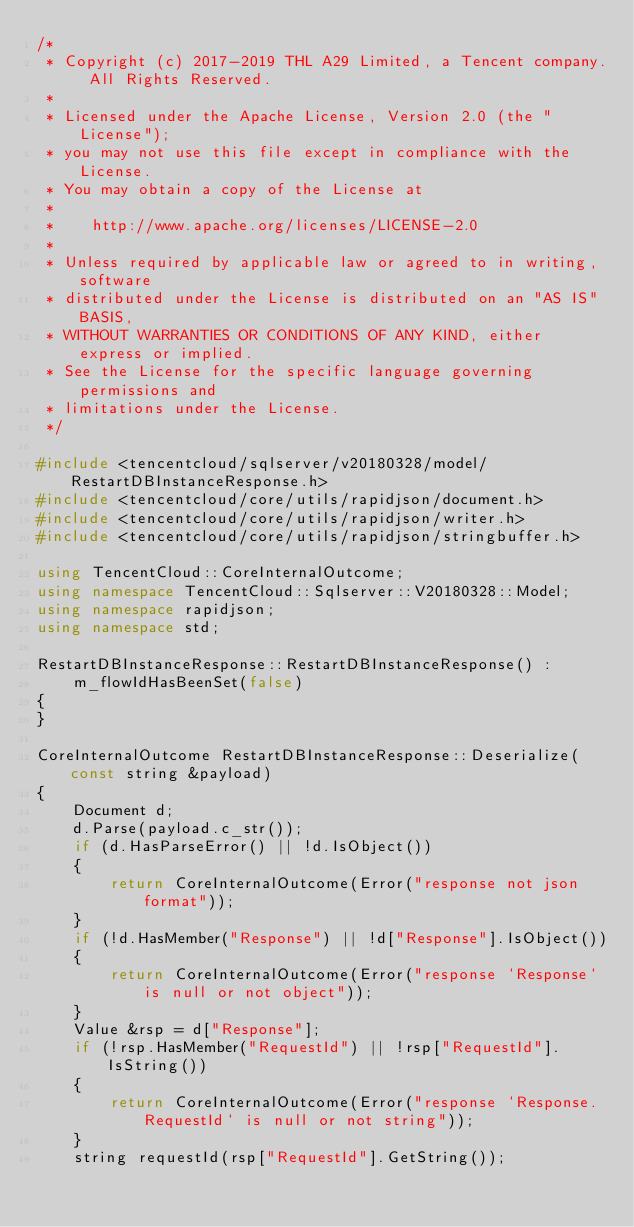<code> <loc_0><loc_0><loc_500><loc_500><_C++_>/*
 * Copyright (c) 2017-2019 THL A29 Limited, a Tencent company. All Rights Reserved.
 *
 * Licensed under the Apache License, Version 2.0 (the "License");
 * you may not use this file except in compliance with the License.
 * You may obtain a copy of the License at
 *
 *    http://www.apache.org/licenses/LICENSE-2.0
 *
 * Unless required by applicable law or agreed to in writing, software
 * distributed under the License is distributed on an "AS IS" BASIS,
 * WITHOUT WARRANTIES OR CONDITIONS OF ANY KIND, either express or implied.
 * See the License for the specific language governing permissions and
 * limitations under the License.
 */

#include <tencentcloud/sqlserver/v20180328/model/RestartDBInstanceResponse.h>
#include <tencentcloud/core/utils/rapidjson/document.h>
#include <tencentcloud/core/utils/rapidjson/writer.h>
#include <tencentcloud/core/utils/rapidjson/stringbuffer.h>

using TencentCloud::CoreInternalOutcome;
using namespace TencentCloud::Sqlserver::V20180328::Model;
using namespace rapidjson;
using namespace std;

RestartDBInstanceResponse::RestartDBInstanceResponse() :
    m_flowIdHasBeenSet(false)
{
}

CoreInternalOutcome RestartDBInstanceResponse::Deserialize(const string &payload)
{
    Document d;
    d.Parse(payload.c_str());
    if (d.HasParseError() || !d.IsObject())
    {
        return CoreInternalOutcome(Error("response not json format"));
    }
    if (!d.HasMember("Response") || !d["Response"].IsObject())
    {
        return CoreInternalOutcome(Error("response `Response` is null or not object"));
    }
    Value &rsp = d["Response"];
    if (!rsp.HasMember("RequestId") || !rsp["RequestId"].IsString())
    {
        return CoreInternalOutcome(Error("response `Response.RequestId` is null or not string"));
    }
    string requestId(rsp["RequestId"].GetString());</code> 